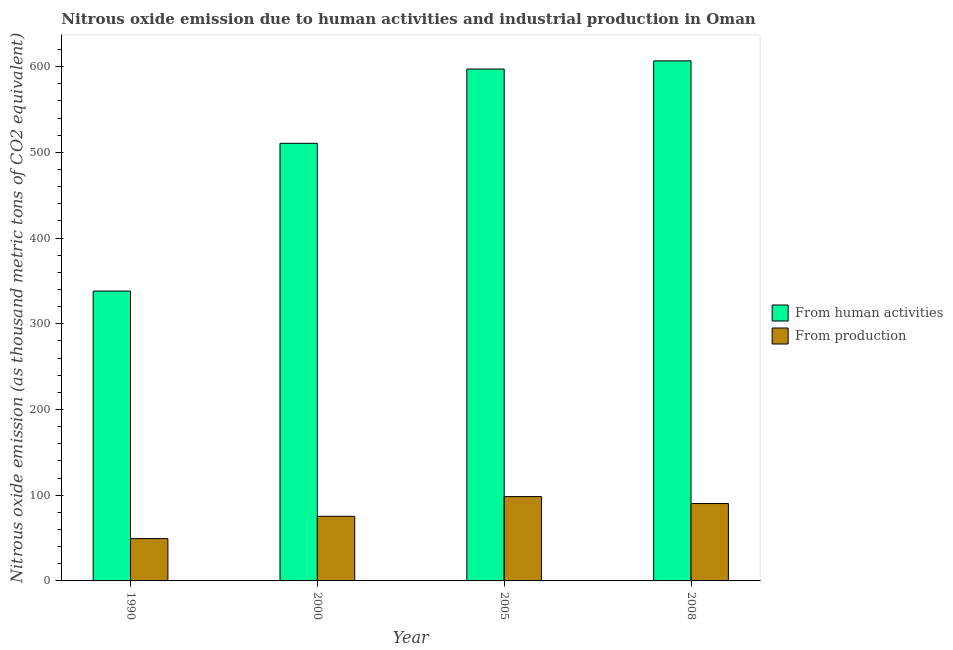How many different coloured bars are there?
Provide a short and direct response. 2. How many groups of bars are there?
Offer a very short reply. 4. Are the number of bars per tick equal to the number of legend labels?
Provide a short and direct response. Yes. How many bars are there on the 4th tick from the left?
Offer a terse response. 2. What is the amount of emissions generated from industries in 2000?
Offer a terse response. 75.4. Across all years, what is the maximum amount of emissions from human activities?
Offer a terse response. 606.8. Across all years, what is the minimum amount of emissions generated from industries?
Provide a succinct answer. 49.4. What is the total amount of emissions from human activities in the graph?
Provide a short and direct response. 2052.9. What is the difference between the amount of emissions from human activities in 1990 and that in 2005?
Your response must be concise. -259.1. What is the difference between the amount of emissions generated from industries in 1990 and the amount of emissions from human activities in 2005?
Make the answer very short. -49. What is the average amount of emissions generated from industries per year?
Keep it short and to the point. 78.38. In the year 2008, what is the difference between the amount of emissions generated from industries and amount of emissions from human activities?
Give a very brief answer. 0. In how many years, is the amount of emissions from human activities greater than 320 thousand metric tons?
Provide a short and direct response. 4. What is the ratio of the amount of emissions from human activities in 1990 to that in 2005?
Offer a very short reply. 0.57. Is the amount of emissions generated from industries in 2000 less than that in 2005?
Ensure brevity in your answer.  Yes. Is the difference between the amount of emissions from human activities in 1990 and 2000 greater than the difference between the amount of emissions generated from industries in 1990 and 2000?
Offer a very short reply. No. What is the difference between the highest and the second highest amount of emissions from human activities?
Your answer should be very brief. 9.5. What is the difference between the highest and the lowest amount of emissions from human activities?
Provide a succinct answer. 268.6. In how many years, is the amount of emissions from human activities greater than the average amount of emissions from human activities taken over all years?
Your answer should be compact. 2. What does the 1st bar from the left in 1990 represents?
Ensure brevity in your answer.  From human activities. What does the 2nd bar from the right in 1990 represents?
Ensure brevity in your answer.  From human activities. How many bars are there?
Keep it short and to the point. 8. Are all the bars in the graph horizontal?
Keep it short and to the point. No. How many years are there in the graph?
Keep it short and to the point. 4. What is the difference between two consecutive major ticks on the Y-axis?
Provide a short and direct response. 100. Does the graph contain any zero values?
Offer a very short reply. No. How are the legend labels stacked?
Your response must be concise. Vertical. What is the title of the graph?
Make the answer very short. Nitrous oxide emission due to human activities and industrial production in Oman. What is the label or title of the Y-axis?
Provide a short and direct response. Nitrous oxide emission (as thousand metric tons of CO2 equivalent). What is the Nitrous oxide emission (as thousand metric tons of CO2 equivalent) of From human activities in 1990?
Offer a terse response. 338.2. What is the Nitrous oxide emission (as thousand metric tons of CO2 equivalent) in From production in 1990?
Provide a short and direct response. 49.4. What is the Nitrous oxide emission (as thousand metric tons of CO2 equivalent) in From human activities in 2000?
Make the answer very short. 510.6. What is the Nitrous oxide emission (as thousand metric tons of CO2 equivalent) of From production in 2000?
Your answer should be compact. 75.4. What is the Nitrous oxide emission (as thousand metric tons of CO2 equivalent) of From human activities in 2005?
Provide a succinct answer. 597.3. What is the Nitrous oxide emission (as thousand metric tons of CO2 equivalent) in From production in 2005?
Keep it short and to the point. 98.4. What is the Nitrous oxide emission (as thousand metric tons of CO2 equivalent) of From human activities in 2008?
Offer a very short reply. 606.8. What is the Nitrous oxide emission (as thousand metric tons of CO2 equivalent) of From production in 2008?
Your answer should be very brief. 90.3. Across all years, what is the maximum Nitrous oxide emission (as thousand metric tons of CO2 equivalent) in From human activities?
Offer a terse response. 606.8. Across all years, what is the maximum Nitrous oxide emission (as thousand metric tons of CO2 equivalent) of From production?
Provide a succinct answer. 98.4. Across all years, what is the minimum Nitrous oxide emission (as thousand metric tons of CO2 equivalent) in From human activities?
Offer a very short reply. 338.2. Across all years, what is the minimum Nitrous oxide emission (as thousand metric tons of CO2 equivalent) in From production?
Your answer should be compact. 49.4. What is the total Nitrous oxide emission (as thousand metric tons of CO2 equivalent) in From human activities in the graph?
Keep it short and to the point. 2052.9. What is the total Nitrous oxide emission (as thousand metric tons of CO2 equivalent) in From production in the graph?
Keep it short and to the point. 313.5. What is the difference between the Nitrous oxide emission (as thousand metric tons of CO2 equivalent) in From human activities in 1990 and that in 2000?
Offer a terse response. -172.4. What is the difference between the Nitrous oxide emission (as thousand metric tons of CO2 equivalent) of From human activities in 1990 and that in 2005?
Keep it short and to the point. -259.1. What is the difference between the Nitrous oxide emission (as thousand metric tons of CO2 equivalent) of From production in 1990 and that in 2005?
Make the answer very short. -49. What is the difference between the Nitrous oxide emission (as thousand metric tons of CO2 equivalent) in From human activities in 1990 and that in 2008?
Your response must be concise. -268.6. What is the difference between the Nitrous oxide emission (as thousand metric tons of CO2 equivalent) in From production in 1990 and that in 2008?
Your response must be concise. -40.9. What is the difference between the Nitrous oxide emission (as thousand metric tons of CO2 equivalent) of From human activities in 2000 and that in 2005?
Ensure brevity in your answer.  -86.7. What is the difference between the Nitrous oxide emission (as thousand metric tons of CO2 equivalent) of From human activities in 2000 and that in 2008?
Offer a very short reply. -96.2. What is the difference between the Nitrous oxide emission (as thousand metric tons of CO2 equivalent) of From production in 2000 and that in 2008?
Your answer should be compact. -14.9. What is the difference between the Nitrous oxide emission (as thousand metric tons of CO2 equivalent) in From human activities in 2005 and that in 2008?
Provide a succinct answer. -9.5. What is the difference between the Nitrous oxide emission (as thousand metric tons of CO2 equivalent) in From production in 2005 and that in 2008?
Your response must be concise. 8.1. What is the difference between the Nitrous oxide emission (as thousand metric tons of CO2 equivalent) in From human activities in 1990 and the Nitrous oxide emission (as thousand metric tons of CO2 equivalent) in From production in 2000?
Give a very brief answer. 262.8. What is the difference between the Nitrous oxide emission (as thousand metric tons of CO2 equivalent) of From human activities in 1990 and the Nitrous oxide emission (as thousand metric tons of CO2 equivalent) of From production in 2005?
Provide a succinct answer. 239.8. What is the difference between the Nitrous oxide emission (as thousand metric tons of CO2 equivalent) of From human activities in 1990 and the Nitrous oxide emission (as thousand metric tons of CO2 equivalent) of From production in 2008?
Make the answer very short. 247.9. What is the difference between the Nitrous oxide emission (as thousand metric tons of CO2 equivalent) in From human activities in 2000 and the Nitrous oxide emission (as thousand metric tons of CO2 equivalent) in From production in 2005?
Your answer should be very brief. 412.2. What is the difference between the Nitrous oxide emission (as thousand metric tons of CO2 equivalent) in From human activities in 2000 and the Nitrous oxide emission (as thousand metric tons of CO2 equivalent) in From production in 2008?
Your answer should be compact. 420.3. What is the difference between the Nitrous oxide emission (as thousand metric tons of CO2 equivalent) of From human activities in 2005 and the Nitrous oxide emission (as thousand metric tons of CO2 equivalent) of From production in 2008?
Offer a terse response. 507. What is the average Nitrous oxide emission (as thousand metric tons of CO2 equivalent) in From human activities per year?
Provide a short and direct response. 513.23. What is the average Nitrous oxide emission (as thousand metric tons of CO2 equivalent) of From production per year?
Keep it short and to the point. 78.38. In the year 1990, what is the difference between the Nitrous oxide emission (as thousand metric tons of CO2 equivalent) in From human activities and Nitrous oxide emission (as thousand metric tons of CO2 equivalent) in From production?
Provide a short and direct response. 288.8. In the year 2000, what is the difference between the Nitrous oxide emission (as thousand metric tons of CO2 equivalent) of From human activities and Nitrous oxide emission (as thousand metric tons of CO2 equivalent) of From production?
Keep it short and to the point. 435.2. In the year 2005, what is the difference between the Nitrous oxide emission (as thousand metric tons of CO2 equivalent) in From human activities and Nitrous oxide emission (as thousand metric tons of CO2 equivalent) in From production?
Your answer should be compact. 498.9. In the year 2008, what is the difference between the Nitrous oxide emission (as thousand metric tons of CO2 equivalent) of From human activities and Nitrous oxide emission (as thousand metric tons of CO2 equivalent) of From production?
Provide a succinct answer. 516.5. What is the ratio of the Nitrous oxide emission (as thousand metric tons of CO2 equivalent) of From human activities in 1990 to that in 2000?
Offer a terse response. 0.66. What is the ratio of the Nitrous oxide emission (as thousand metric tons of CO2 equivalent) of From production in 1990 to that in 2000?
Give a very brief answer. 0.66. What is the ratio of the Nitrous oxide emission (as thousand metric tons of CO2 equivalent) in From human activities in 1990 to that in 2005?
Your response must be concise. 0.57. What is the ratio of the Nitrous oxide emission (as thousand metric tons of CO2 equivalent) in From production in 1990 to that in 2005?
Provide a succinct answer. 0.5. What is the ratio of the Nitrous oxide emission (as thousand metric tons of CO2 equivalent) of From human activities in 1990 to that in 2008?
Offer a terse response. 0.56. What is the ratio of the Nitrous oxide emission (as thousand metric tons of CO2 equivalent) of From production in 1990 to that in 2008?
Make the answer very short. 0.55. What is the ratio of the Nitrous oxide emission (as thousand metric tons of CO2 equivalent) of From human activities in 2000 to that in 2005?
Keep it short and to the point. 0.85. What is the ratio of the Nitrous oxide emission (as thousand metric tons of CO2 equivalent) of From production in 2000 to that in 2005?
Offer a terse response. 0.77. What is the ratio of the Nitrous oxide emission (as thousand metric tons of CO2 equivalent) of From human activities in 2000 to that in 2008?
Your answer should be compact. 0.84. What is the ratio of the Nitrous oxide emission (as thousand metric tons of CO2 equivalent) of From production in 2000 to that in 2008?
Provide a succinct answer. 0.83. What is the ratio of the Nitrous oxide emission (as thousand metric tons of CO2 equivalent) in From human activities in 2005 to that in 2008?
Your answer should be very brief. 0.98. What is the ratio of the Nitrous oxide emission (as thousand metric tons of CO2 equivalent) of From production in 2005 to that in 2008?
Offer a terse response. 1.09. What is the difference between the highest and the second highest Nitrous oxide emission (as thousand metric tons of CO2 equivalent) in From human activities?
Ensure brevity in your answer.  9.5. What is the difference between the highest and the lowest Nitrous oxide emission (as thousand metric tons of CO2 equivalent) in From human activities?
Your answer should be compact. 268.6. What is the difference between the highest and the lowest Nitrous oxide emission (as thousand metric tons of CO2 equivalent) of From production?
Provide a short and direct response. 49. 